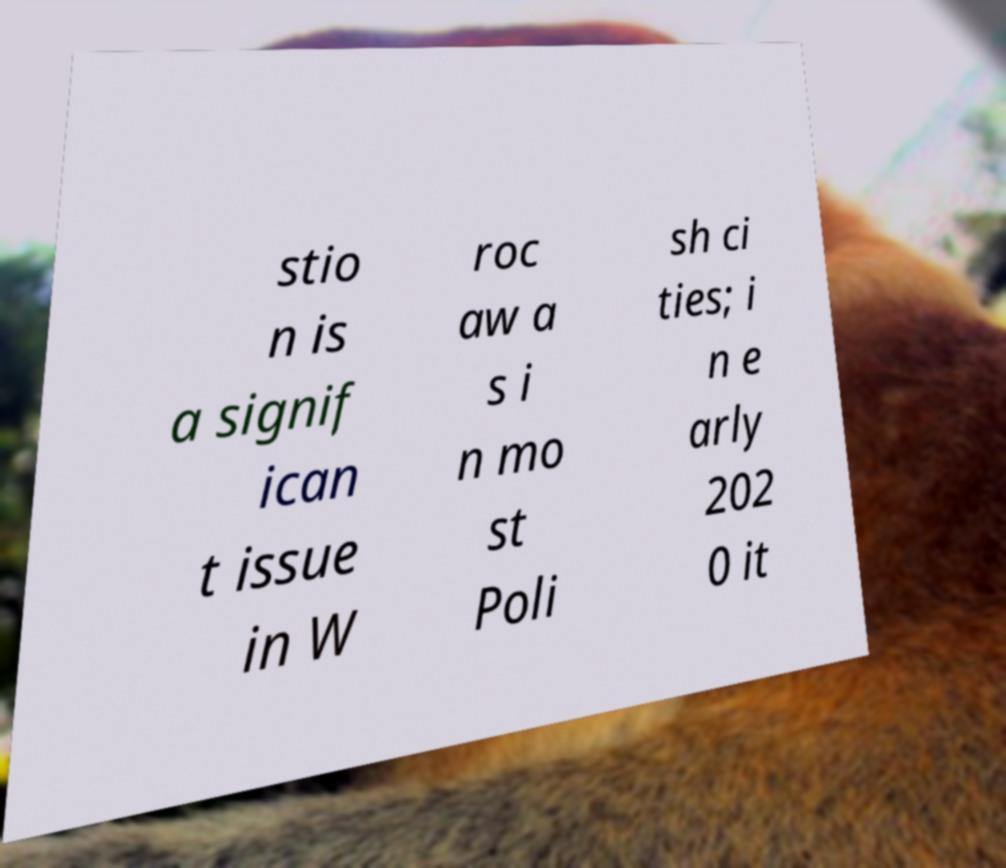Could you extract and type out the text from this image? stio n is a signif ican t issue in W roc aw a s i n mo st Poli sh ci ties; i n e arly 202 0 it 